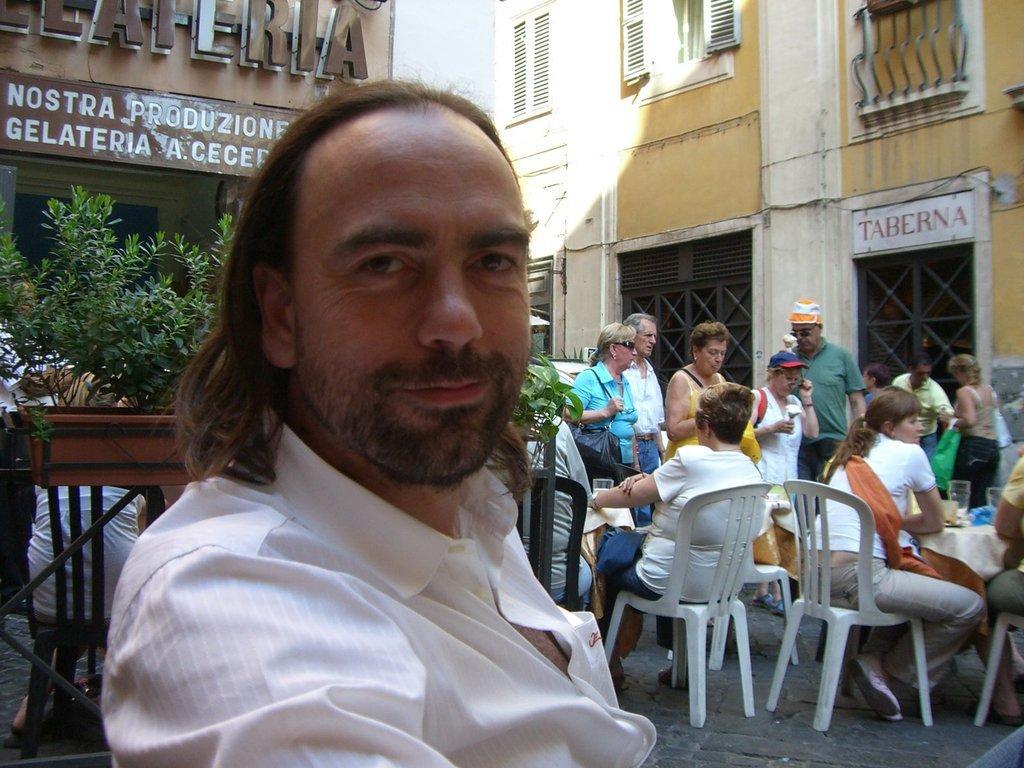Describe this image in one or two sentences. On the left there is a man,behind him there are plants,buildings,windows and few people are sitting on the chair at the table and few are standing. There are glasses on the table. 